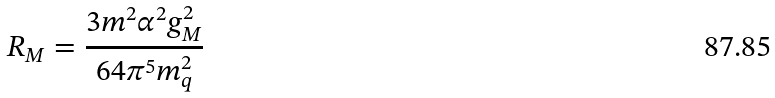<formula> <loc_0><loc_0><loc_500><loc_500>R _ { M } = \frac { 3 m ^ { 2 } \alpha ^ { 2 } g _ { M } ^ { 2 } } { 6 4 \pi ^ { 5 } m _ { q } ^ { 2 } }</formula> 